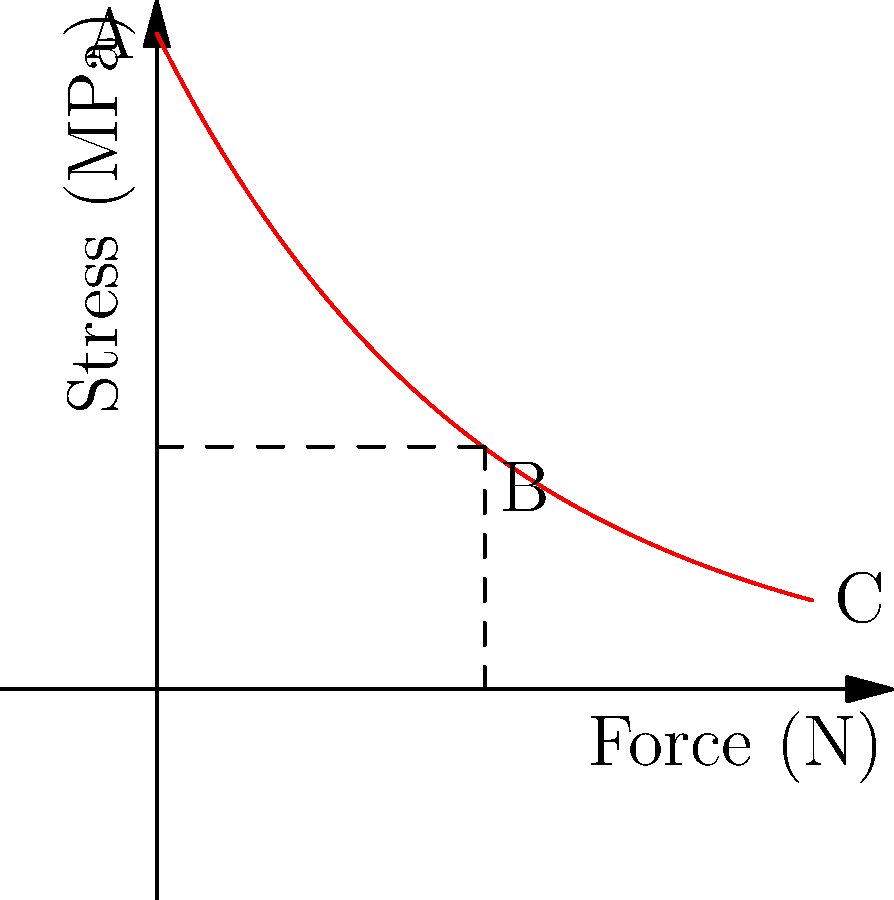The graph shows the stress distribution in a prosthetic leg under load. Point A represents the attachment point, while point C represents the foot. If the maximum allowable stress for the material is 80 MPa, at approximately what distance from point A (in cm) does the stress fall below the maximum allowable limit? To solve this problem, we need to follow these steps:

1. Understand the graph:
   - The x-axis represents the distance along the prosthetic leg (in cm).
   - The y-axis represents the stress (in MPa).
   - The curve shows how stress decreases from the attachment point (A) to the foot (C).

2. Identify the maximum allowable stress:
   - The question states that the maximum allowable stress is 80 MPa.

3. Find the point where the stress equals 80 MPa:
   - We need to find the x-coordinate (distance) where the curve intersects the 80 MPa line.

4. Use the exponential decay equation:
   - The stress distribution follows an exponential decay: $\sigma = \sigma_0 e^{-x/\lambda}$
   - Where $\sigma_0$ is the initial stress (100 MPa at x = 0), and $\lambda$ is the decay constant.

5. Solve the equation:
   $80 = 100 e^{-x/\lambda}$
   $\ln(0.8) = -x/\lambda$
   $x = -\lambda \ln(0.8)$

6. Estimate $\lambda$ from the graph:
   - At x = 50 cm, the stress is about 37 MPa.
   - $37 = 100 e^{-50/\lambda}$
   - $\lambda \approx 50 / \ln(100/37) \approx 43.2$ cm

7. Calculate the distance:
   $x = -43.2 \ln(0.8) \approx 9.7$ cm

Therefore, the stress falls below the maximum allowable limit at approximately 9.7 cm from point A.
Answer: 9.7 cm 